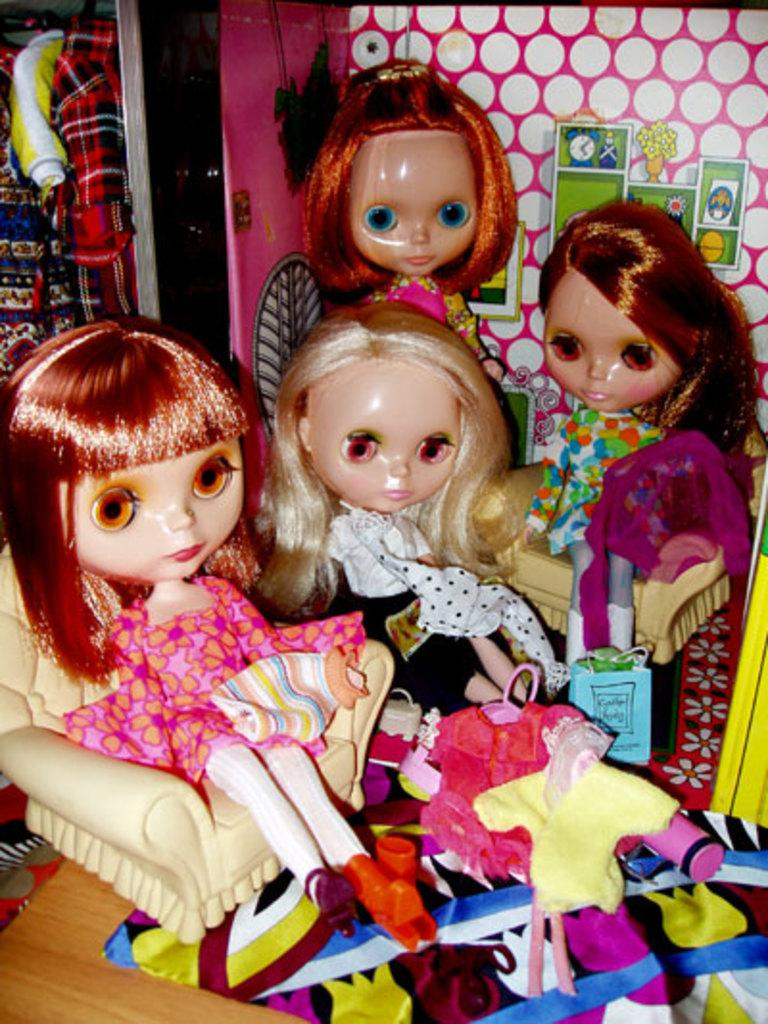What type of objects are present in the image? There are colorful dolls in the image. Can you describe the appearance of the dolls? The dolls are colorful, which suggests they have bright and vibrant colors. Are there any other objects or figures in the image? The image only shows colorful dolls, so there are no other objects or figures present. What grade does the airport receive for its fire safety measures in the image? There is no airport present in the image, so it is not possible to evaluate its fire safety measures or assign a grade. 